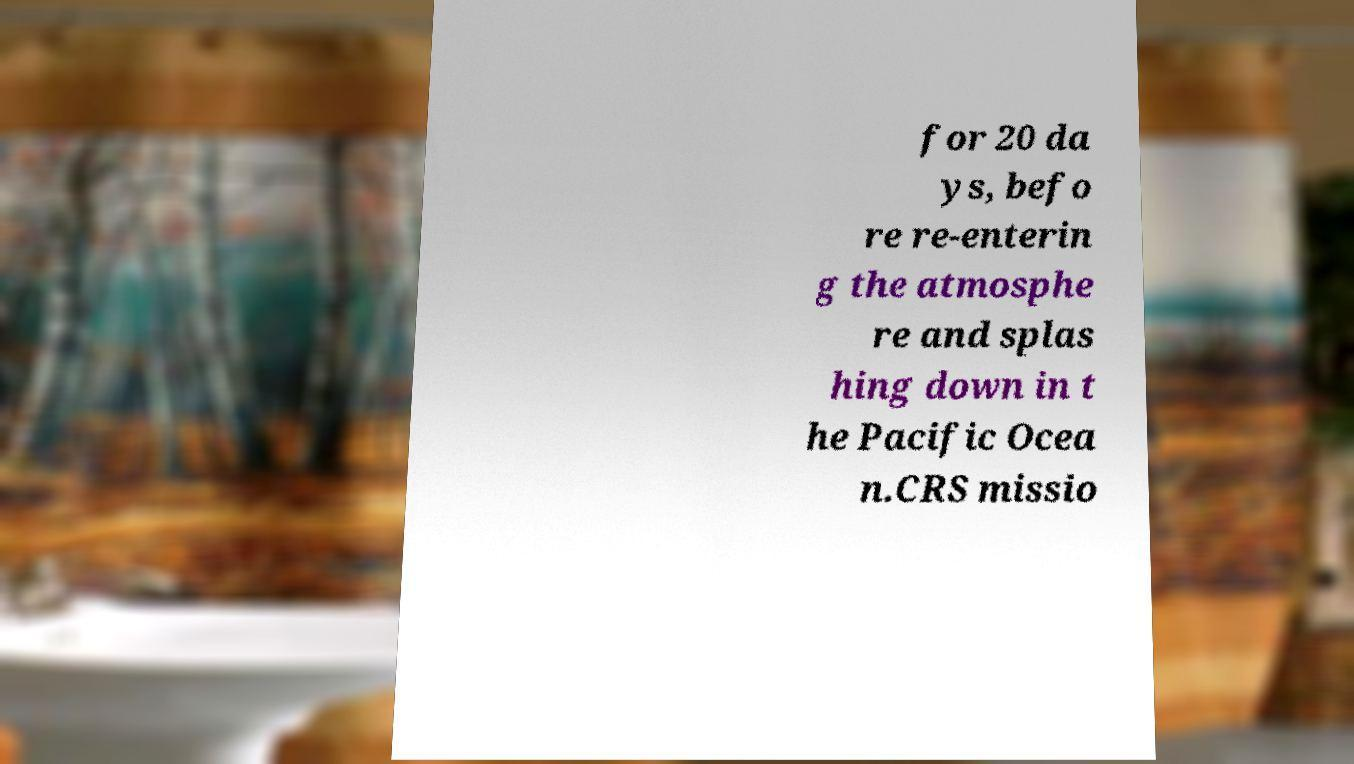Could you extract and type out the text from this image? for 20 da ys, befo re re-enterin g the atmosphe re and splas hing down in t he Pacific Ocea n.CRS missio 